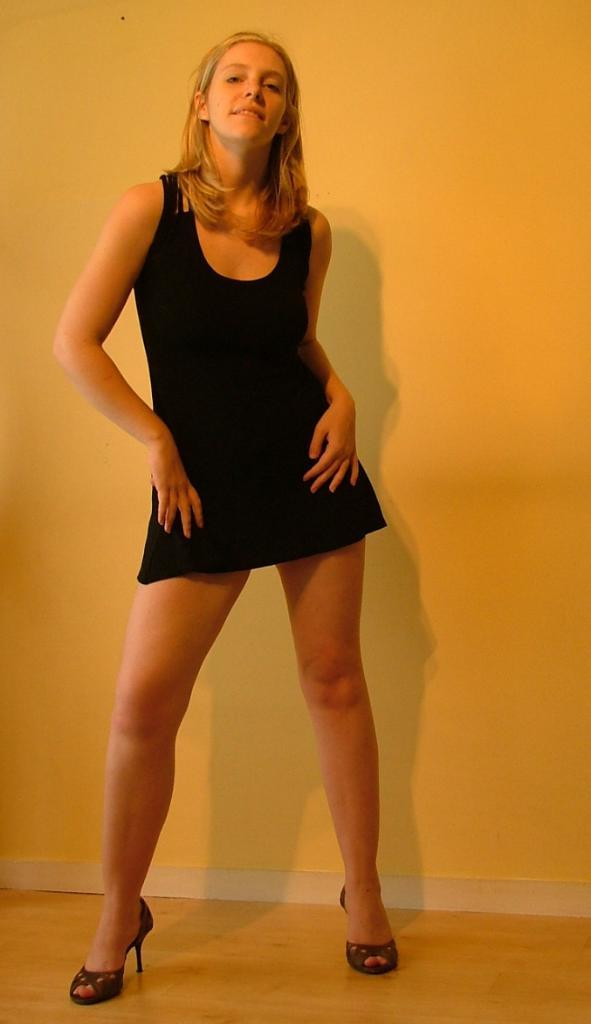Who is the main subject in the image? There is a girl in the image. What is the girl doing in the image? The girl is standing on the floor. What can be seen in the background of the image? There is a wall in the background of the image. What type of account does the girl have in the image? There is no mention of an account in the image, as it features a girl standing on the floor with a wall in the background. 